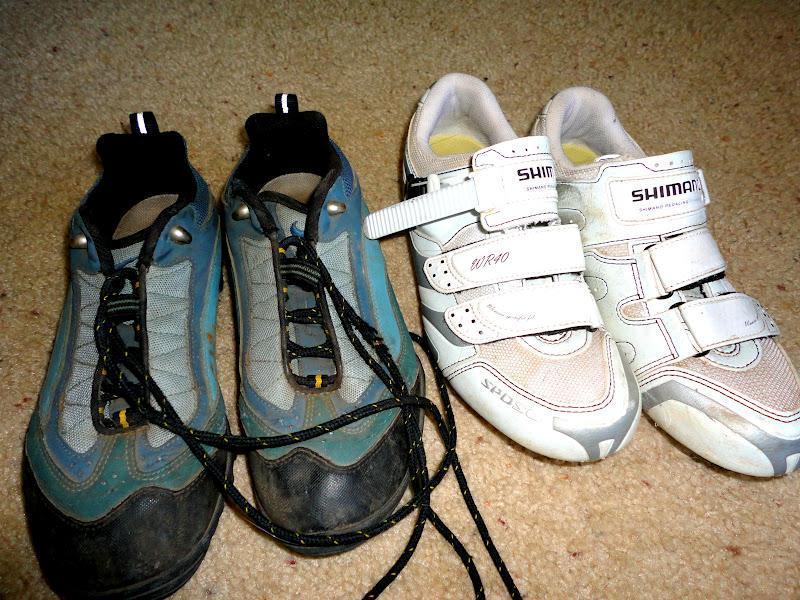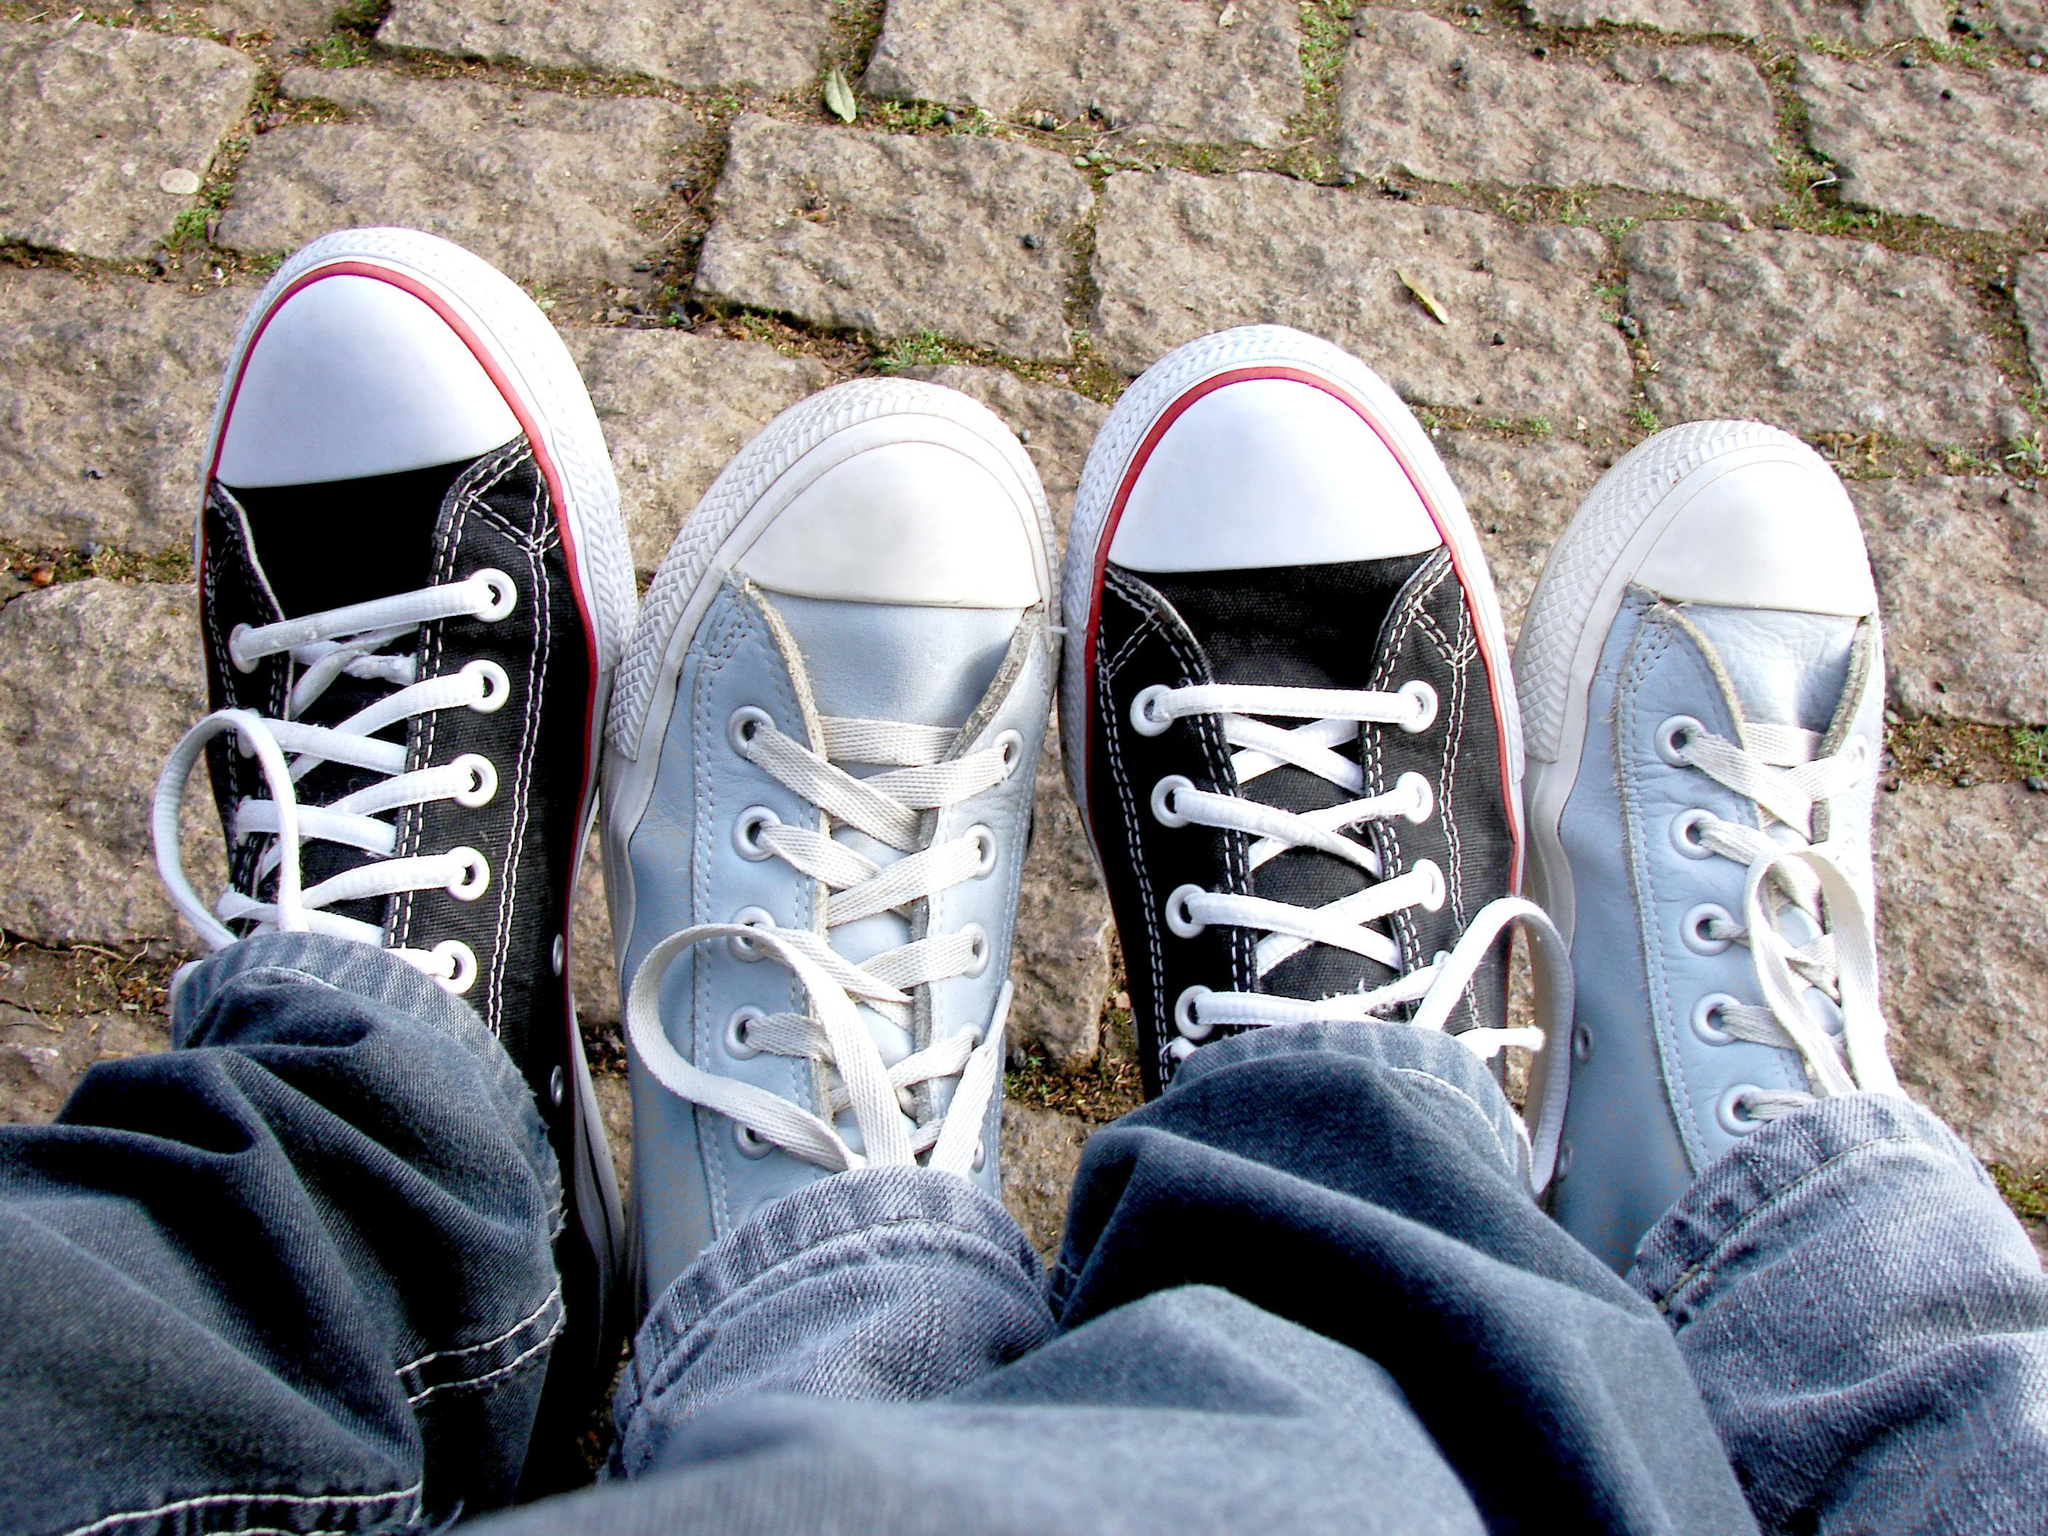The first image is the image on the left, the second image is the image on the right. Given the left and right images, does the statement "There are exactly eight shoes visible." hold true? Answer yes or no. Yes. The first image is the image on the left, the second image is the image on the right. Evaluate the accuracy of this statement regarding the images: "At least one person is wearing the shoes.". Is it true? Answer yes or no. Yes. 